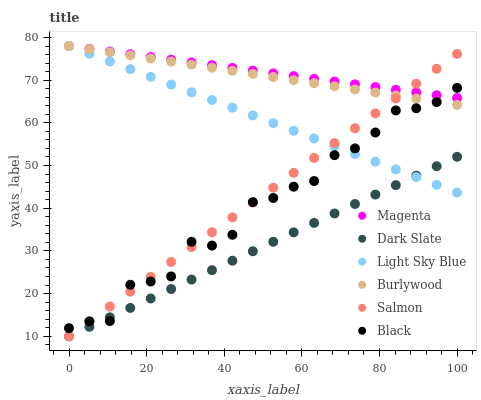Does Dark Slate have the minimum area under the curve?
Answer yes or no. Yes. Does Magenta have the maximum area under the curve?
Answer yes or no. Yes. Does Salmon have the minimum area under the curve?
Answer yes or no. No. Does Salmon have the maximum area under the curve?
Answer yes or no. No. Is Salmon the smoothest?
Answer yes or no. Yes. Is Black the roughest?
Answer yes or no. Yes. Is Dark Slate the smoothest?
Answer yes or no. No. Is Dark Slate the roughest?
Answer yes or no. No. Does Salmon have the lowest value?
Answer yes or no. Yes. Does Light Sky Blue have the lowest value?
Answer yes or no. No. Does Magenta have the highest value?
Answer yes or no. Yes. Does Salmon have the highest value?
Answer yes or no. No. Is Dark Slate less than Burlywood?
Answer yes or no. Yes. Is Magenta greater than Dark Slate?
Answer yes or no. Yes. Does Black intersect Burlywood?
Answer yes or no. Yes. Is Black less than Burlywood?
Answer yes or no. No. Is Black greater than Burlywood?
Answer yes or no. No. Does Dark Slate intersect Burlywood?
Answer yes or no. No. 